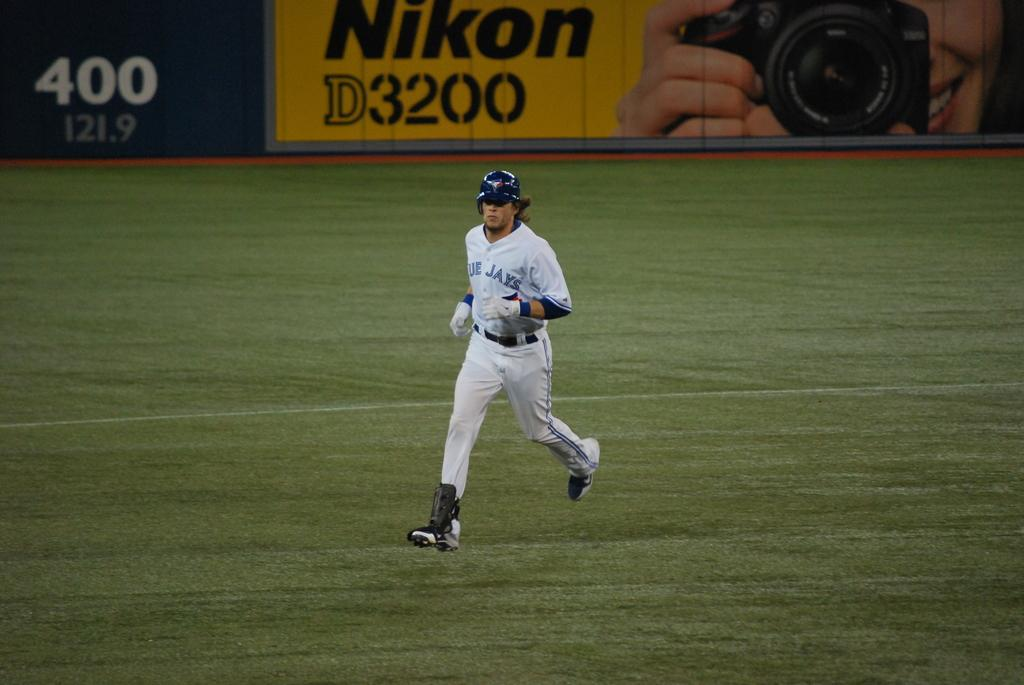<image>
Share a concise interpretation of the image provided. Baseball player for the Blue Jays running on the grass field. 